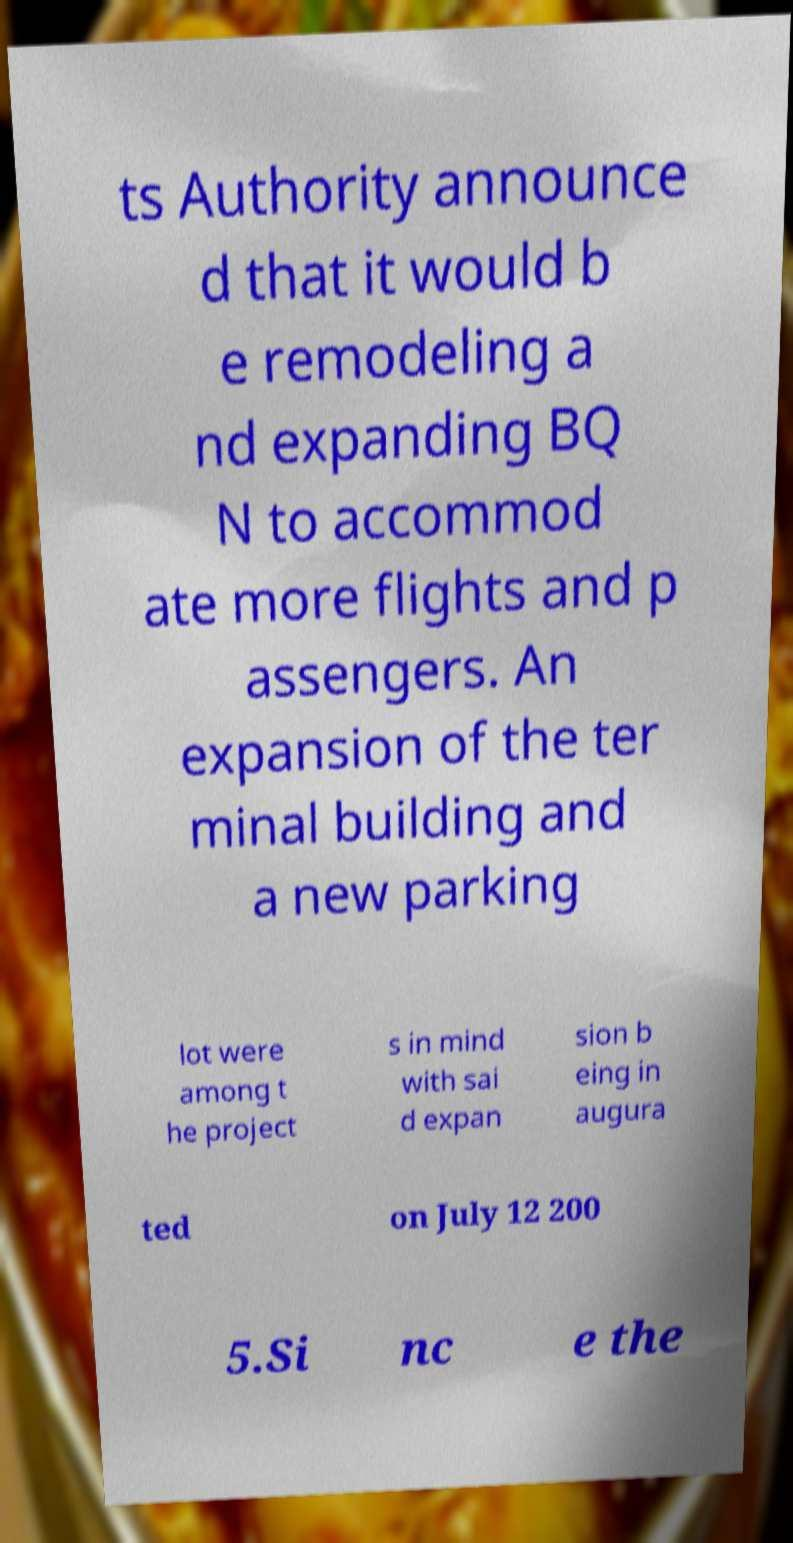Could you assist in decoding the text presented in this image and type it out clearly? ts Authority announce d that it would b e remodeling a nd expanding BQ N to accommod ate more flights and p assengers. An expansion of the ter minal building and a new parking lot were among t he project s in mind with sai d expan sion b eing in augura ted on July 12 200 5.Si nc e the 